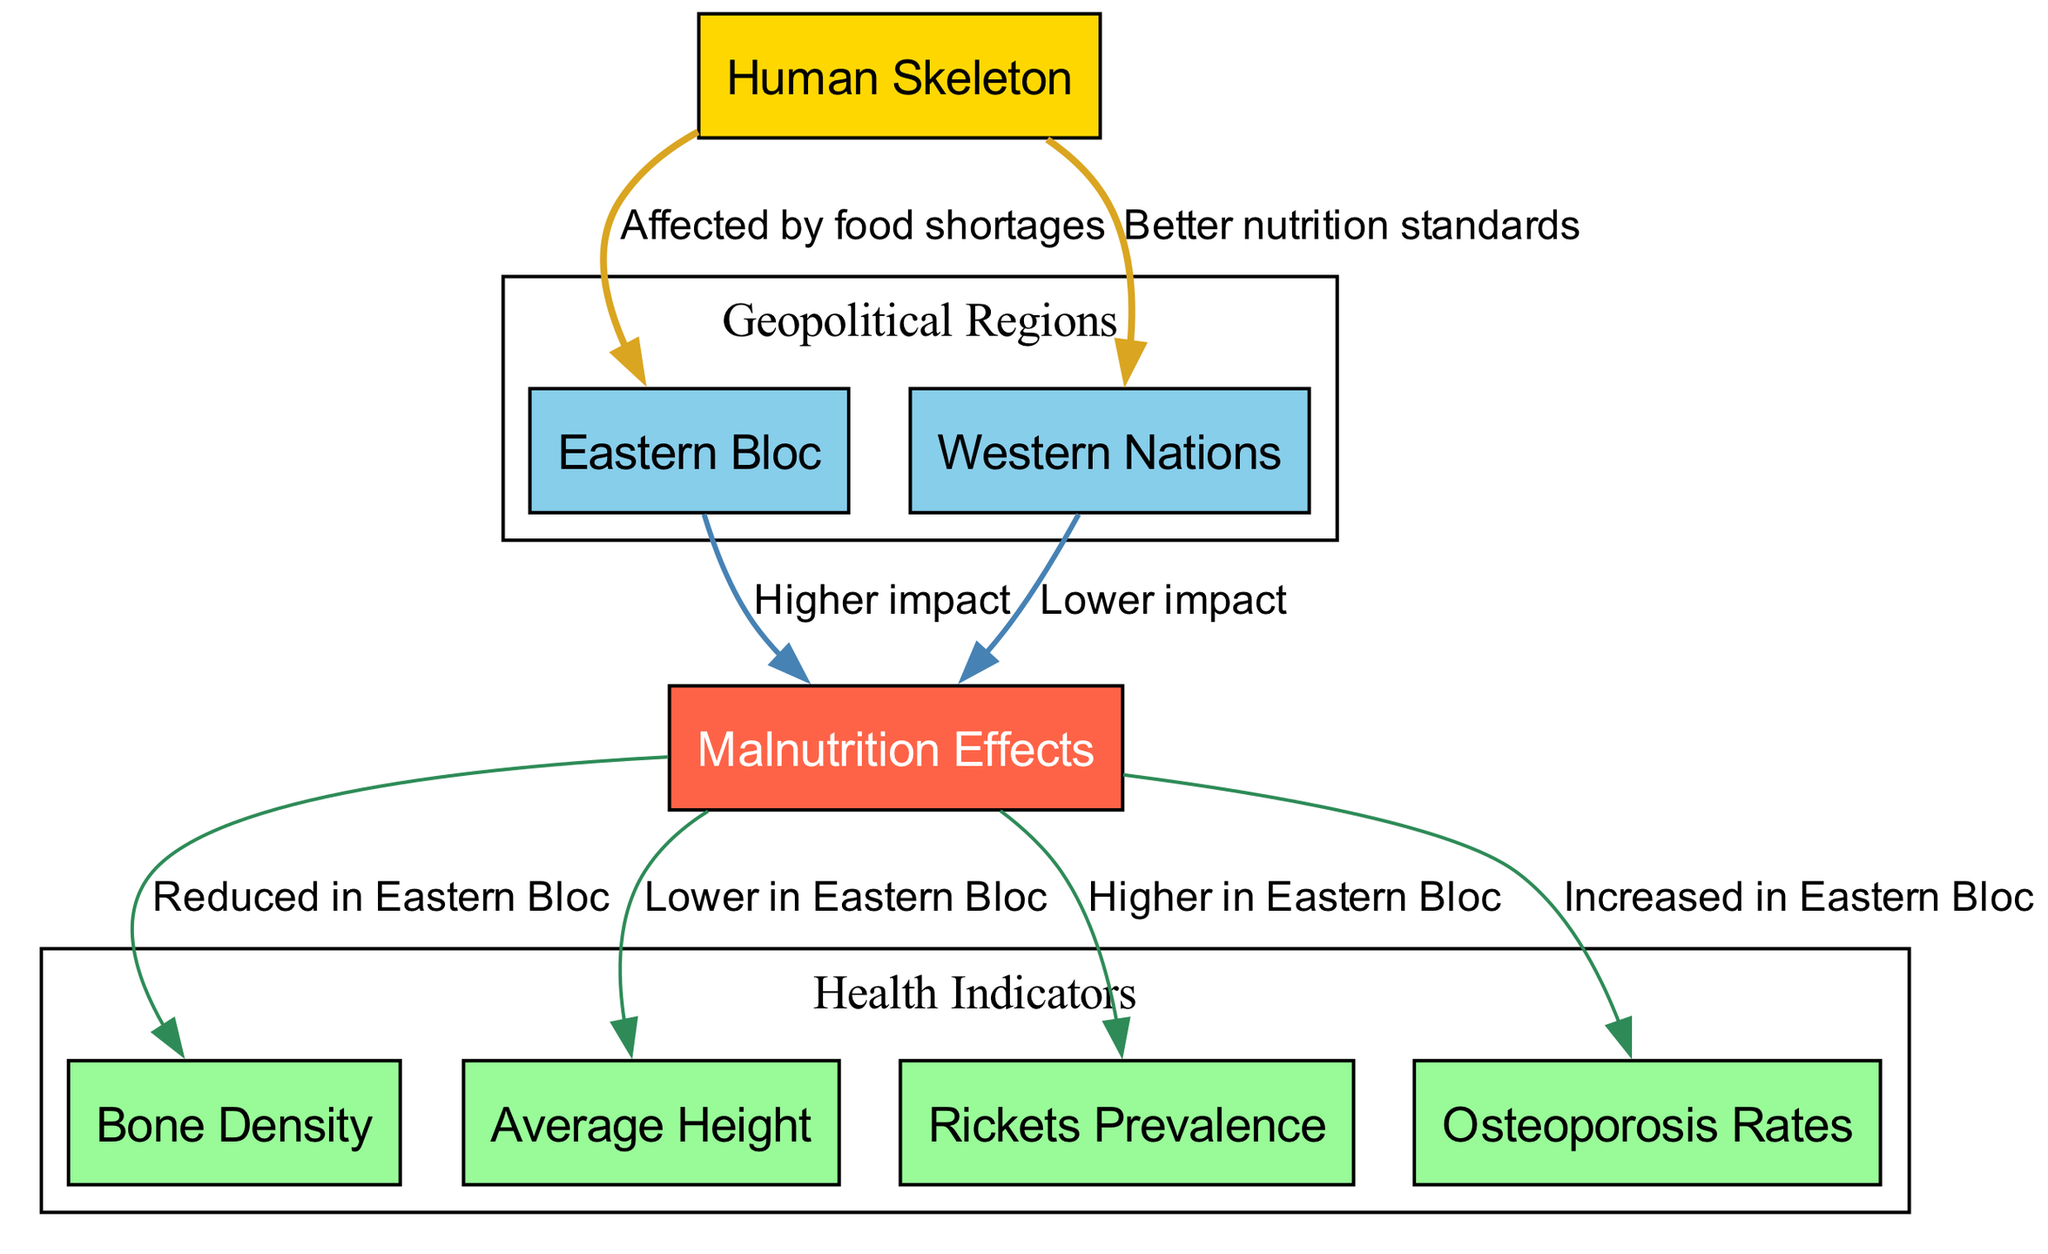What is the central theme of the diagram? The diagram contrasts the human skeletal structures and the effects of malnutrition on populations in Eastern Bloc countries versus Western nations during the Cold War, highlighting the differences in health outcomes.
Answer: Comparative malnutrition effects How many nodes are present in the diagram? The diagram contains a total of eight nodes: Human Skeleton, Eastern Bloc, Western Nations, Malnutrition Effects, Bone Density, Average Height, Rickets Prevalence, and Osteoporosis Rates.
Answer: 8 Which region is depicted as having better nutrition standards? The diagram indicates that Western nations have better nutrition standards compared to Eastern Bloc countries, as shown by the directed edge from "skeleton" to "western_nations".
Answer: Western Nations What health condition has a higher prevalence in the Eastern Bloc? The diagram notes that Rickets prevalence is higher in the Eastern Bloc, represented by the connection from "malnutrition_effects" to "rickets".
Answer: Rickets What is the relationship between malnutrition effects and bone density in the Eastern Bloc? The diagram illustrates that bone density is reduced in the Eastern Bloc as a direct consequence of malnutrition effects, which is indicated by the link between "malnutrition_effects" and "bone_density".
Answer: Reduced in Eastern Bloc How does malnutrition impact average height in the Eastern Bloc compared to Western nations? According to the diagram, malnutrition leads to a lower average height in the Eastern Bloc relative to Western nations, as indicated by the connecting nodes and descriptions.
Answer: Lower in Eastern Bloc Which health issue is increased in the Eastern Bloc due to malnutrition? The diagram states that osteoporosis rates are increased in the Eastern Bloc, shown by the connection from "malnutrition_effects" to "osteoporosis".
Answer: Osteoporosis How does the diagram visually represent the health indicators? The health indicators, such as bone density, average height, rickets, and osteoporosis, are grouped in a designated area within subgraphs to clearly separate them from geopolitical regions, indicating their thematic relevance.
Answer: In subgraphs What can be inferred about the overall health impacts of malnutrition in the Eastern Bloc compared to the Western nations? The diagram suggests that populations in the Eastern Bloc experience more severe health impacts due to malnutrition, as evidenced by higher rates of health issues like rickets and osteoporosis, and lower measurements in bone density and average height.
Answer: Higher impact in Eastern Bloc 